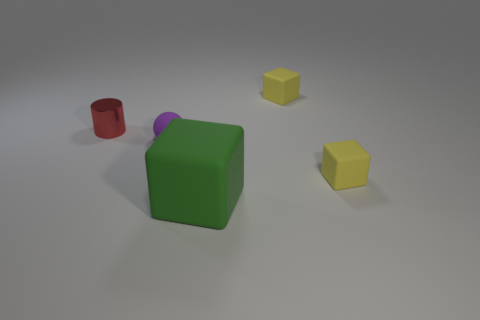Is there any other thing that has the same material as the tiny cylinder?
Keep it short and to the point. No. How many yellow things are either cylinders or blocks?
Make the answer very short. 2. What number of cylinders have the same size as the green rubber object?
Offer a very short reply. 0. There is a thing that is behind the ball and right of the tiny purple ball; what color is it?
Give a very brief answer. Yellow. Is the number of tiny red cylinders in front of the tiny purple rubber sphere greater than the number of large matte cubes?
Offer a terse response. No. Are any red metallic cylinders visible?
Offer a terse response. Yes. Does the sphere have the same color as the big rubber thing?
Offer a very short reply. No. How many big objects are green spheres or green matte objects?
Offer a very short reply. 1. Is there any other thing that has the same color as the rubber sphere?
Keep it short and to the point. No. There is a big thing that is the same material as the tiny purple thing; what is its shape?
Give a very brief answer. Cube. 